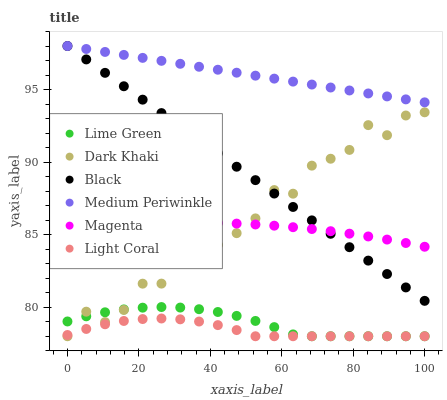Does Light Coral have the minimum area under the curve?
Answer yes or no. Yes. Does Medium Periwinkle have the maximum area under the curve?
Answer yes or no. Yes. Does Dark Khaki have the minimum area under the curve?
Answer yes or no. No. Does Dark Khaki have the maximum area under the curve?
Answer yes or no. No. Is Medium Periwinkle the smoothest?
Answer yes or no. Yes. Is Dark Khaki the roughest?
Answer yes or no. Yes. Is Dark Khaki the smoothest?
Answer yes or no. No. Is Medium Periwinkle the roughest?
Answer yes or no. No. Does Light Coral have the lowest value?
Answer yes or no. Yes. Does Medium Periwinkle have the lowest value?
Answer yes or no. No. Does Black have the highest value?
Answer yes or no. Yes. Does Dark Khaki have the highest value?
Answer yes or no. No. Is Lime Green less than Medium Periwinkle?
Answer yes or no. Yes. Is Medium Periwinkle greater than Dark Khaki?
Answer yes or no. Yes. Does Dark Khaki intersect Light Coral?
Answer yes or no. Yes. Is Dark Khaki less than Light Coral?
Answer yes or no. No. Is Dark Khaki greater than Light Coral?
Answer yes or no. No. Does Lime Green intersect Medium Periwinkle?
Answer yes or no. No. 